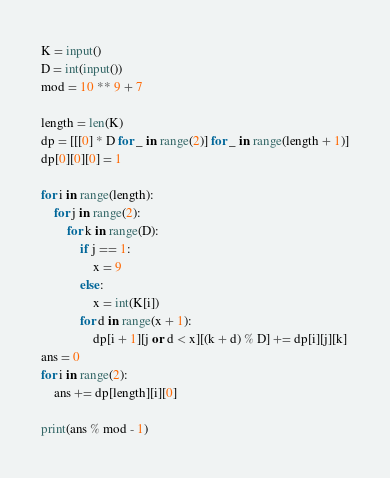<code> <loc_0><loc_0><loc_500><loc_500><_Python_>K = input()
D = int(input())
mod = 10 ** 9 + 7

length = len(K)
dp = [[[0] * D for _ in range(2)] for _ in range(length + 1)]
dp[0][0][0] = 1

for i in range(length):
    for j in range(2):
        for k in range(D):
            if j == 1:
                x = 9
            else:
                x = int(K[i])
            for d in range(x + 1):
                dp[i + 1][j or d < x][(k + d) % D] += dp[i][j][k]
ans = 0
for i in range(2):
    ans += dp[length][i][0]

print(ans % mod - 1)
</code> 